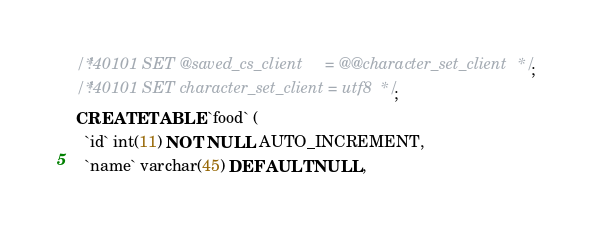<code> <loc_0><loc_0><loc_500><loc_500><_SQL_>/*!40101 SET @saved_cs_client     = @@character_set_client */;
/*!40101 SET character_set_client = utf8 */;
CREATE TABLE `food` (
  `id` int(11) NOT NULL AUTO_INCREMENT,
  `name` varchar(45) DEFAULT NULL,</code> 